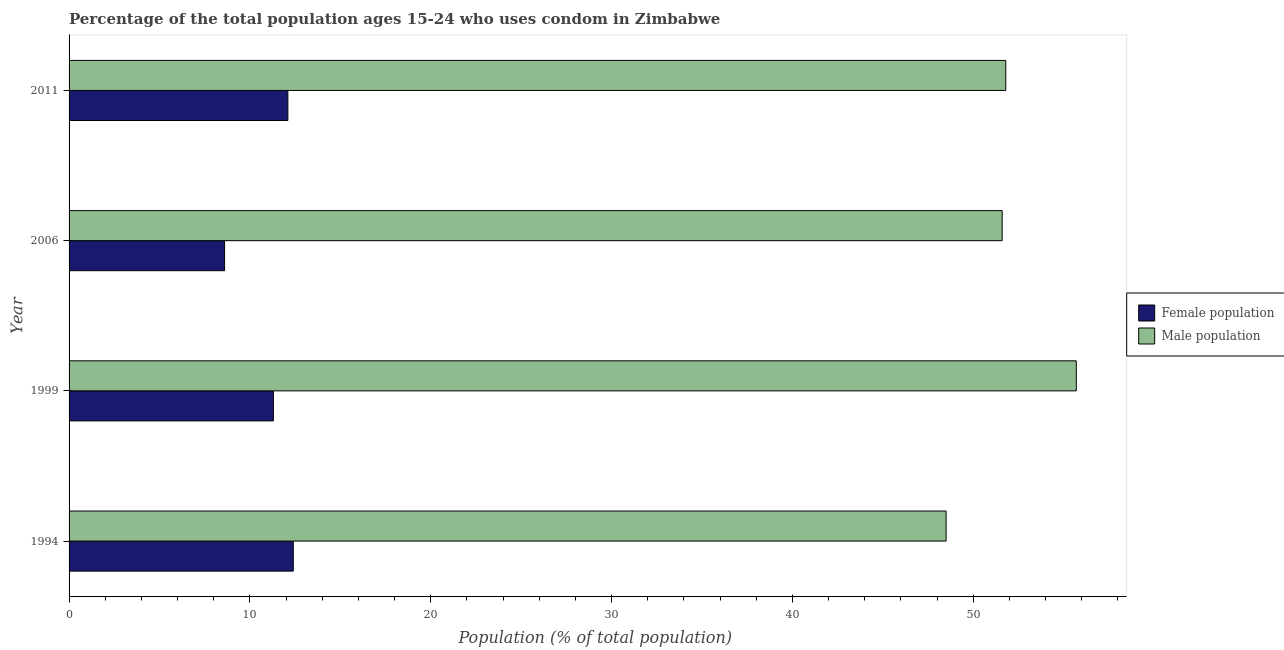How many different coloured bars are there?
Keep it short and to the point. 2. How many groups of bars are there?
Keep it short and to the point. 4. Are the number of bars per tick equal to the number of legend labels?
Your answer should be compact. Yes. How many bars are there on the 1st tick from the bottom?
Your answer should be very brief. 2. What is the label of the 2nd group of bars from the top?
Your response must be concise. 2006. Across all years, what is the minimum male population?
Ensure brevity in your answer.  48.5. In which year was the male population minimum?
Your answer should be compact. 1994. What is the total female population in the graph?
Ensure brevity in your answer.  44.4. What is the difference between the female population in 2006 and that in 2011?
Offer a terse response. -3.5. What is the difference between the female population in 1994 and the male population in 1999?
Give a very brief answer. -43.3. What is the average male population per year?
Keep it short and to the point. 51.9. In the year 1994, what is the difference between the female population and male population?
Offer a terse response. -36.1. What is the ratio of the male population in 1999 to that in 2006?
Offer a terse response. 1.08. Is the female population in 1994 less than that in 2006?
Your answer should be compact. No. Is the difference between the male population in 2006 and 2011 greater than the difference between the female population in 2006 and 2011?
Your response must be concise. Yes. What is the difference between the highest and the lowest female population?
Ensure brevity in your answer.  3.8. What does the 2nd bar from the top in 2006 represents?
Ensure brevity in your answer.  Female population. What does the 1st bar from the bottom in 2006 represents?
Ensure brevity in your answer.  Female population. How many bars are there?
Your response must be concise. 8. How many years are there in the graph?
Keep it short and to the point. 4. What is the difference between two consecutive major ticks on the X-axis?
Keep it short and to the point. 10. Where does the legend appear in the graph?
Your answer should be compact. Center right. What is the title of the graph?
Your answer should be compact. Percentage of the total population ages 15-24 who uses condom in Zimbabwe. Does "Primary" appear as one of the legend labels in the graph?
Make the answer very short. No. What is the label or title of the X-axis?
Offer a terse response. Population (% of total population) . What is the label or title of the Y-axis?
Offer a very short reply. Year. What is the Population (% of total population)  of Male population in 1994?
Ensure brevity in your answer.  48.5. What is the Population (% of total population)  of Female population in 1999?
Your response must be concise. 11.3. What is the Population (% of total population)  of Male population in 1999?
Offer a terse response. 55.7. What is the Population (% of total population)  of Male population in 2006?
Provide a succinct answer. 51.6. What is the Population (% of total population)  in Male population in 2011?
Keep it short and to the point. 51.8. Across all years, what is the maximum Population (% of total population)  in Female population?
Offer a very short reply. 12.4. Across all years, what is the maximum Population (% of total population)  in Male population?
Ensure brevity in your answer.  55.7. Across all years, what is the minimum Population (% of total population)  of Male population?
Keep it short and to the point. 48.5. What is the total Population (% of total population)  in Female population in the graph?
Ensure brevity in your answer.  44.4. What is the total Population (% of total population)  in Male population in the graph?
Make the answer very short. 207.6. What is the difference between the Population (% of total population)  in Female population in 1994 and that in 1999?
Your answer should be very brief. 1.1. What is the difference between the Population (% of total population)  of Male population in 1994 and that in 2006?
Provide a succinct answer. -3.1. What is the difference between the Population (% of total population)  in Female population in 1994 and that in 2011?
Keep it short and to the point. 0.3. What is the difference between the Population (% of total population)  of Male population in 1994 and that in 2011?
Make the answer very short. -3.3. What is the difference between the Population (% of total population)  in Female population in 1999 and that in 2006?
Give a very brief answer. 2.7. What is the difference between the Population (% of total population)  of Male population in 2006 and that in 2011?
Make the answer very short. -0.2. What is the difference between the Population (% of total population)  of Female population in 1994 and the Population (% of total population)  of Male population in 1999?
Your answer should be very brief. -43.3. What is the difference between the Population (% of total population)  of Female population in 1994 and the Population (% of total population)  of Male population in 2006?
Give a very brief answer. -39.2. What is the difference between the Population (% of total population)  in Female population in 1994 and the Population (% of total population)  in Male population in 2011?
Provide a short and direct response. -39.4. What is the difference between the Population (% of total population)  in Female population in 1999 and the Population (% of total population)  in Male population in 2006?
Give a very brief answer. -40.3. What is the difference between the Population (% of total population)  of Female population in 1999 and the Population (% of total population)  of Male population in 2011?
Keep it short and to the point. -40.5. What is the difference between the Population (% of total population)  in Female population in 2006 and the Population (% of total population)  in Male population in 2011?
Provide a short and direct response. -43.2. What is the average Population (% of total population)  in Female population per year?
Offer a terse response. 11.1. What is the average Population (% of total population)  of Male population per year?
Give a very brief answer. 51.9. In the year 1994, what is the difference between the Population (% of total population)  in Female population and Population (% of total population)  in Male population?
Ensure brevity in your answer.  -36.1. In the year 1999, what is the difference between the Population (% of total population)  in Female population and Population (% of total population)  in Male population?
Offer a very short reply. -44.4. In the year 2006, what is the difference between the Population (% of total population)  in Female population and Population (% of total population)  in Male population?
Your answer should be compact. -43. In the year 2011, what is the difference between the Population (% of total population)  of Female population and Population (% of total population)  of Male population?
Keep it short and to the point. -39.7. What is the ratio of the Population (% of total population)  in Female population in 1994 to that in 1999?
Provide a succinct answer. 1.1. What is the ratio of the Population (% of total population)  of Male population in 1994 to that in 1999?
Keep it short and to the point. 0.87. What is the ratio of the Population (% of total population)  in Female population in 1994 to that in 2006?
Give a very brief answer. 1.44. What is the ratio of the Population (% of total population)  of Male population in 1994 to that in 2006?
Ensure brevity in your answer.  0.94. What is the ratio of the Population (% of total population)  in Female population in 1994 to that in 2011?
Offer a terse response. 1.02. What is the ratio of the Population (% of total population)  of Male population in 1994 to that in 2011?
Your answer should be compact. 0.94. What is the ratio of the Population (% of total population)  of Female population in 1999 to that in 2006?
Offer a terse response. 1.31. What is the ratio of the Population (% of total population)  of Male population in 1999 to that in 2006?
Your answer should be compact. 1.08. What is the ratio of the Population (% of total population)  of Female population in 1999 to that in 2011?
Give a very brief answer. 0.93. What is the ratio of the Population (% of total population)  of Male population in 1999 to that in 2011?
Make the answer very short. 1.08. What is the ratio of the Population (% of total population)  of Female population in 2006 to that in 2011?
Keep it short and to the point. 0.71. What is the ratio of the Population (% of total population)  of Male population in 2006 to that in 2011?
Keep it short and to the point. 1. What is the difference between the highest and the second highest Population (% of total population)  in Female population?
Your response must be concise. 0.3. What is the difference between the highest and the second highest Population (% of total population)  in Male population?
Keep it short and to the point. 3.9. What is the difference between the highest and the lowest Population (% of total population)  in Male population?
Make the answer very short. 7.2. 